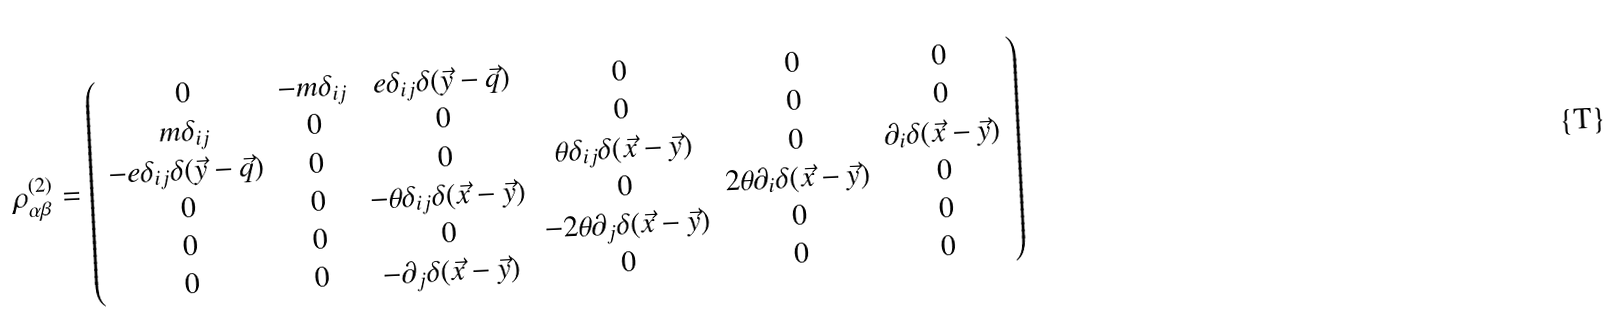Convert formula to latex. <formula><loc_0><loc_0><loc_500><loc_500>\rho ^ { ( 2 ) } _ { \alpha \beta } = \left ( \begin{array} { c c c c c c } 0 & - m \delta _ { i j } & e \delta _ { i j } \delta ( \vec { y } - \vec { q } ) & 0 & 0 & 0 \\ m \delta _ { i j } & 0 & 0 & 0 & 0 & 0 \\ - e \delta _ { i j } \delta ( \vec { y } - \vec { q } ) & 0 & 0 & \theta \delta _ { i j } \delta ( \vec { x } - \vec { y } ) & 0 & \partial _ { i } \delta ( \vec { x } - \vec { y } ) \\ 0 & 0 & - \theta \delta _ { i j } \delta ( \vec { x } - \vec { y } ) & 0 & 2 \theta \partial _ { i } \delta ( \vec { x } - \vec { y } ) & 0 \\ 0 & 0 & 0 & - 2 \theta \partial _ { j } \delta ( \vec { x } - \vec { y } ) & 0 & 0 \\ 0 & 0 & - \partial _ { j } \delta ( \vec { x } - \vec { y } ) & 0 & 0 & 0 \end{array} \right )</formula> 